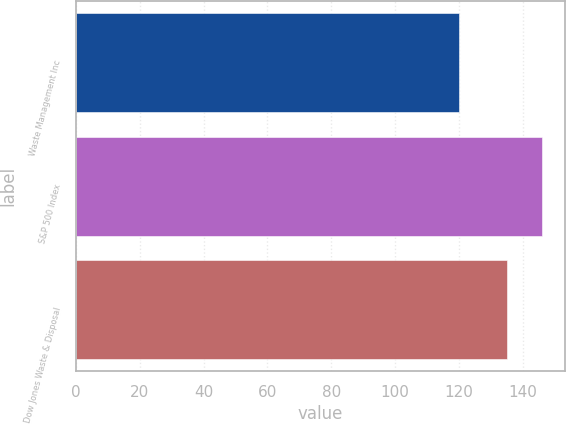Convert chart to OTSL. <chart><loc_0><loc_0><loc_500><loc_500><bar_chart><fcel>Waste Management Inc<fcel>S&P 500 Index<fcel>Dow Jones Waste & Disposal<nl><fcel>120<fcel>146<fcel>135<nl></chart> 